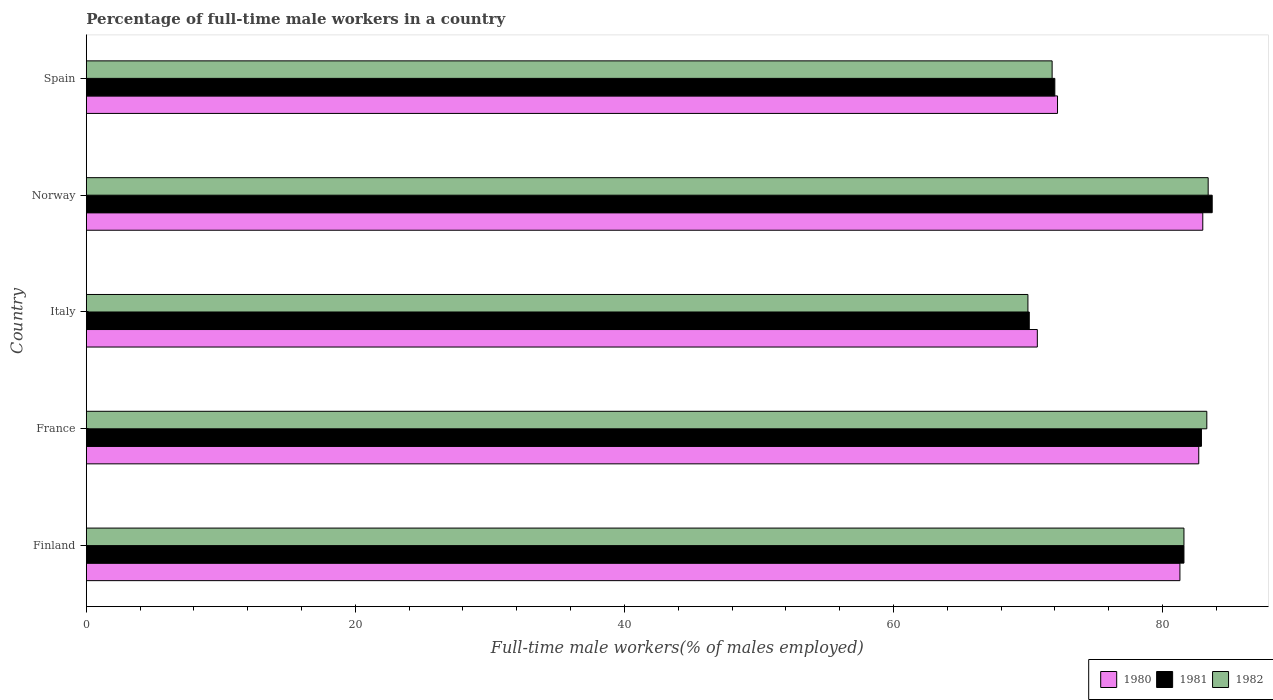How many groups of bars are there?
Make the answer very short. 5. How many bars are there on the 2nd tick from the top?
Offer a terse response. 3. What is the label of the 5th group of bars from the top?
Offer a terse response. Finland. In how many cases, is the number of bars for a given country not equal to the number of legend labels?
Give a very brief answer. 0. What is the percentage of full-time male workers in 1982 in Finland?
Provide a succinct answer. 81.6. Across all countries, what is the maximum percentage of full-time male workers in 1982?
Give a very brief answer. 83.4. Across all countries, what is the minimum percentage of full-time male workers in 1980?
Give a very brief answer. 70.7. In which country was the percentage of full-time male workers in 1980 maximum?
Offer a very short reply. Norway. In which country was the percentage of full-time male workers in 1980 minimum?
Keep it short and to the point. Italy. What is the total percentage of full-time male workers in 1982 in the graph?
Offer a terse response. 390.1. What is the difference between the percentage of full-time male workers in 1982 in Italy and that in Spain?
Keep it short and to the point. -1.8. What is the difference between the percentage of full-time male workers in 1980 in Spain and the percentage of full-time male workers in 1981 in Italy?
Give a very brief answer. 2.1. What is the average percentage of full-time male workers in 1981 per country?
Your answer should be compact. 78.06. What is the difference between the percentage of full-time male workers in 1981 and percentage of full-time male workers in 1982 in Italy?
Make the answer very short. 0.1. What is the ratio of the percentage of full-time male workers in 1981 in Finland to that in Norway?
Keep it short and to the point. 0.97. Is the percentage of full-time male workers in 1980 in Italy less than that in Spain?
Ensure brevity in your answer.  Yes. Is the difference between the percentage of full-time male workers in 1981 in France and Spain greater than the difference between the percentage of full-time male workers in 1982 in France and Spain?
Keep it short and to the point. No. What is the difference between the highest and the second highest percentage of full-time male workers in 1981?
Keep it short and to the point. 0.8. What is the difference between the highest and the lowest percentage of full-time male workers in 1981?
Your response must be concise. 13.6. In how many countries, is the percentage of full-time male workers in 1981 greater than the average percentage of full-time male workers in 1981 taken over all countries?
Your answer should be very brief. 3. What does the 1st bar from the bottom in Italy represents?
Provide a short and direct response. 1980. Are all the bars in the graph horizontal?
Offer a terse response. Yes. Are the values on the major ticks of X-axis written in scientific E-notation?
Keep it short and to the point. No. How many legend labels are there?
Provide a short and direct response. 3. How are the legend labels stacked?
Your response must be concise. Horizontal. What is the title of the graph?
Provide a succinct answer. Percentage of full-time male workers in a country. What is the label or title of the X-axis?
Offer a very short reply. Full-time male workers(% of males employed). What is the label or title of the Y-axis?
Your response must be concise. Country. What is the Full-time male workers(% of males employed) in 1980 in Finland?
Offer a terse response. 81.3. What is the Full-time male workers(% of males employed) in 1981 in Finland?
Offer a very short reply. 81.6. What is the Full-time male workers(% of males employed) in 1982 in Finland?
Provide a short and direct response. 81.6. What is the Full-time male workers(% of males employed) of 1980 in France?
Ensure brevity in your answer.  82.7. What is the Full-time male workers(% of males employed) in 1981 in France?
Make the answer very short. 82.9. What is the Full-time male workers(% of males employed) of 1982 in France?
Provide a short and direct response. 83.3. What is the Full-time male workers(% of males employed) in 1980 in Italy?
Your response must be concise. 70.7. What is the Full-time male workers(% of males employed) of 1981 in Italy?
Give a very brief answer. 70.1. What is the Full-time male workers(% of males employed) in 1982 in Italy?
Your answer should be compact. 70. What is the Full-time male workers(% of males employed) in 1980 in Norway?
Your response must be concise. 83. What is the Full-time male workers(% of males employed) of 1981 in Norway?
Ensure brevity in your answer.  83.7. What is the Full-time male workers(% of males employed) of 1982 in Norway?
Offer a terse response. 83.4. What is the Full-time male workers(% of males employed) in 1980 in Spain?
Your answer should be compact. 72.2. What is the Full-time male workers(% of males employed) of 1981 in Spain?
Offer a terse response. 72. What is the Full-time male workers(% of males employed) in 1982 in Spain?
Your response must be concise. 71.8. Across all countries, what is the maximum Full-time male workers(% of males employed) in 1981?
Ensure brevity in your answer.  83.7. Across all countries, what is the maximum Full-time male workers(% of males employed) in 1982?
Your answer should be compact. 83.4. Across all countries, what is the minimum Full-time male workers(% of males employed) of 1980?
Offer a very short reply. 70.7. Across all countries, what is the minimum Full-time male workers(% of males employed) of 1981?
Offer a terse response. 70.1. What is the total Full-time male workers(% of males employed) in 1980 in the graph?
Provide a succinct answer. 389.9. What is the total Full-time male workers(% of males employed) in 1981 in the graph?
Offer a very short reply. 390.3. What is the total Full-time male workers(% of males employed) in 1982 in the graph?
Your answer should be very brief. 390.1. What is the difference between the Full-time male workers(% of males employed) in 1981 in Finland and that in France?
Keep it short and to the point. -1.3. What is the difference between the Full-time male workers(% of males employed) of 1980 in Finland and that in Italy?
Keep it short and to the point. 10.6. What is the difference between the Full-time male workers(% of males employed) in 1980 in Finland and that in Norway?
Make the answer very short. -1.7. What is the difference between the Full-time male workers(% of males employed) in 1981 in Finland and that in Norway?
Provide a succinct answer. -2.1. What is the difference between the Full-time male workers(% of males employed) of 1982 in Finland and that in Norway?
Your response must be concise. -1.8. What is the difference between the Full-time male workers(% of males employed) of 1980 in Finland and that in Spain?
Ensure brevity in your answer.  9.1. What is the difference between the Full-time male workers(% of males employed) of 1981 in Finland and that in Spain?
Make the answer very short. 9.6. What is the difference between the Full-time male workers(% of males employed) of 1982 in Finland and that in Spain?
Offer a very short reply. 9.8. What is the difference between the Full-time male workers(% of males employed) in 1982 in France and that in Norway?
Make the answer very short. -0.1. What is the difference between the Full-time male workers(% of males employed) in 1981 in France and that in Spain?
Give a very brief answer. 10.9. What is the difference between the Full-time male workers(% of males employed) in 1982 in France and that in Spain?
Your answer should be very brief. 11.5. What is the difference between the Full-time male workers(% of males employed) of 1981 in Italy and that in Norway?
Ensure brevity in your answer.  -13.6. What is the difference between the Full-time male workers(% of males employed) of 1982 in Italy and that in Norway?
Make the answer very short. -13.4. What is the difference between the Full-time male workers(% of males employed) in 1980 in Italy and that in Spain?
Your response must be concise. -1.5. What is the difference between the Full-time male workers(% of males employed) in 1982 in Italy and that in Spain?
Ensure brevity in your answer.  -1.8. What is the difference between the Full-time male workers(% of males employed) in 1981 in Norway and that in Spain?
Your response must be concise. 11.7. What is the difference between the Full-time male workers(% of males employed) in 1980 in Finland and the Full-time male workers(% of males employed) in 1982 in France?
Give a very brief answer. -2. What is the difference between the Full-time male workers(% of males employed) of 1980 in Finland and the Full-time male workers(% of males employed) of 1981 in Italy?
Provide a succinct answer. 11.2. What is the difference between the Full-time male workers(% of males employed) of 1980 in Finland and the Full-time male workers(% of males employed) of 1982 in Italy?
Provide a short and direct response. 11.3. What is the difference between the Full-time male workers(% of males employed) in 1981 in Finland and the Full-time male workers(% of males employed) in 1982 in Italy?
Your answer should be very brief. 11.6. What is the difference between the Full-time male workers(% of males employed) in 1980 in Finland and the Full-time male workers(% of males employed) in 1982 in Norway?
Offer a very short reply. -2.1. What is the difference between the Full-time male workers(% of males employed) in 1981 in Finland and the Full-time male workers(% of males employed) in 1982 in Norway?
Keep it short and to the point. -1.8. What is the difference between the Full-time male workers(% of males employed) in 1980 in Finland and the Full-time male workers(% of males employed) in 1981 in Spain?
Offer a very short reply. 9.3. What is the difference between the Full-time male workers(% of males employed) of 1981 in Finland and the Full-time male workers(% of males employed) of 1982 in Spain?
Provide a short and direct response. 9.8. What is the difference between the Full-time male workers(% of males employed) in 1980 in France and the Full-time male workers(% of males employed) in 1982 in Italy?
Ensure brevity in your answer.  12.7. What is the difference between the Full-time male workers(% of males employed) in 1981 in France and the Full-time male workers(% of males employed) in 1982 in Italy?
Offer a very short reply. 12.9. What is the difference between the Full-time male workers(% of males employed) in 1980 in France and the Full-time male workers(% of males employed) in 1982 in Norway?
Your answer should be compact. -0.7. What is the difference between the Full-time male workers(% of males employed) in 1981 in France and the Full-time male workers(% of males employed) in 1982 in Norway?
Your answer should be very brief. -0.5. What is the difference between the Full-time male workers(% of males employed) of 1980 in Italy and the Full-time male workers(% of males employed) of 1982 in Norway?
Make the answer very short. -12.7. What is the difference between the Full-time male workers(% of males employed) in 1981 in Italy and the Full-time male workers(% of males employed) in 1982 in Norway?
Ensure brevity in your answer.  -13.3. What is the difference between the Full-time male workers(% of males employed) of 1980 in Italy and the Full-time male workers(% of males employed) of 1981 in Spain?
Keep it short and to the point. -1.3. What is the difference between the Full-time male workers(% of males employed) in 1981 in Italy and the Full-time male workers(% of males employed) in 1982 in Spain?
Provide a succinct answer. -1.7. What is the difference between the Full-time male workers(% of males employed) of 1980 in Norway and the Full-time male workers(% of males employed) of 1981 in Spain?
Your response must be concise. 11. What is the average Full-time male workers(% of males employed) of 1980 per country?
Provide a succinct answer. 77.98. What is the average Full-time male workers(% of males employed) in 1981 per country?
Provide a short and direct response. 78.06. What is the average Full-time male workers(% of males employed) of 1982 per country?
Give a very brief answer. 78.02. What is the difference between the Full-time male workers(% of males employed) of 1981 and Full-time male workers(% of males employed) of 1982 in Finland?
Ensure brevity in your answer.  0. What is the difference between the Full-time male workers(% of males employed) of 1980 and Full-time male workers(% of males employed) of 1982 in France?
Your response must be concise. -0.6. What is the difference between the Full-time male workers(% of males employed) in 1981 and Full-time male workers(% of males employed) in 1982 in France?
Give a very brief answer. -0.4. What is the difference between the Full-time male workers(% of males employed) in 1980 and Full-time male workers(% of males employed) in 1982 in Italy?
Provide a succinct answer. 0.7. What is the difference between the Full-time male workers(% of males employed) of 1981 and Full-time male workers(% of males employed) of 1982 in Italy?
Make the answer very short. 0.1. What is the difference between the Full-time male workers(% of males employed) in 1980 and Full-time male workers(% of males employed) in 1981 in Norway?
Provide a succinct answer. -0.7. What is the difference between the Full-time male workers(% of males employed) in 1980 and Full-time male workers(% of males employed) in 1982 in Spain?
Give a very brief answer. 0.4. What is the ratio of the Full-time male workers(% of males employed) of 1980 in Finland to that in France?
Ensure brevity in your answer.  0.98. What is the ratio of the Full-time male workers(% of males employed) in 1981 in Finland to that in France?
Your answer should be compact. 0.98. What is the ratio of the Full-time male workers(% of males employed) in 1982 in Finland to that in France?
Make the answer very short. 0.98. What is the ratio of the Full-time male workers(% of males employed) in 1980 in Finland to that in Italy?
Make the answer very short. 1.15. What is the ratio of the Full-time male workers(% of males employed) of 1981 in Finland to that in Italy?
Offer a very short reply. 1.16. What is the ratio of the Full-time male workers(% of males employed) of 1982 in Finland to that in Italy?
Ensure brevity in your answer.  1.17. What is the ratio of the Full-time male workers(% of males employed) of 1980 in Finland to that in Norway?
Provide a succinct answer. 0.98. What is the ratio of the Full-time male workers(% of males employed) of 1981 in Finland to that in Norway?
Provide a short and direct response. 0.97. What is the ratio of the Full-time male workers(% of males employed) in 1982 in Finland to that in Norway?
Provide a short and direct response. 0.98. What is the ratio of the Full-time male workers(% of males employed) of 1980 in Finland to that in Spain?
Provide a short and direct response. 1.13. What is the ratio of the Full-time male workers(% of males employed) in 1981 in Finland to that in Spain?
Your response must be concise. 1.13. What is the ratio of the Full-time male workers(% of males employed) in 1982 in Finland to that in Spain?
Keep it short and to the point. 1.14. What is the ratio of the Full-time male workers(% of males employed) of 1980 in France to that in Italy?
Provide a short and direct response. 1.17. What is the ratio of the Full-time male workers(% of males employed) of 1981 in France to that in Italy?
Keep it short and to the point. 1.18. What is the ratio of the Full-time male workers(% of males employed) of 1982 in France to that in Italy?
Offer a very short reply. 1.19. What is the ratio of the Full-time male workers(% of males employed) in 1980 in France to that in Norway?
Your answer should be very brief. 1. What is the ratio of the Full-time male workers(% of males employed) of 1980 in France to that in Spain?
Your answer should be compact. 1.15. What is the ratio of the Full-time male workers(% of males employed) of 1981 in France to that in Spain?
Offer a very short reply. 1.15. What is the ratio of the Full-time male workers(% of males employed) of 1982 in France to that in Spain?
Ensure brevity in your answer.  1.16. What is the ratio of the Full-time male workers(% of males employed) of 1980 in Italy to that in Norway?
Provide a succinct answer. 0.85. What is the ratio of the Full-time male workers(% of males employed) in 1981 in Italy to that in Norway?
Offer a terse response. 0.84. What is the ratio of the Full-time male workers(% of males employed) in 1982 in Italy to that in Norway?
Keep it short and to the point. 0.84. What is the ratio of the Full-time male workers(% of males employed) in 1980 in Italy to that in Spain?
Make the answer very short. 0.98. What is the ratio of the Full-time male workers(% of males employed) in 1981 in Italy to that in Spain?
Ensure brevity in your answer.  0.97. What is the ratio of the Full-time male workers(% of males employed) of 1982 in Italy to that in Spain?
Ensure brevity in your answer.  0.97. What is the ratio of the Full-time male workers(% of males employed) in 1980 in Norway to that in Spain?
Ensure brevity in your answer.  1.15. What is the ratio of the Full-time male workers(% of males employed) of 1981 in Norway to that in Spain?
Give a very brief answer. 1.16. What is the ratio of the Full-time male workers(% of males employed) of 1982 in Norway to that in Spain?
Give a very brief answer. 1.16. What is the difference between the highest and the second highest Full-time male workers(% of males employed) in 1981?
Provide a succinct answer. 0.8. What is the difference between the highest and the second highest Full-time male workers(% of males employed) of 1982?
Offer a terse response. 0.1. What is the difference between the highest and the lowest Full-time male workers(% of males employed) of 1982?
Ensure brevity in your answer.  13.4. 